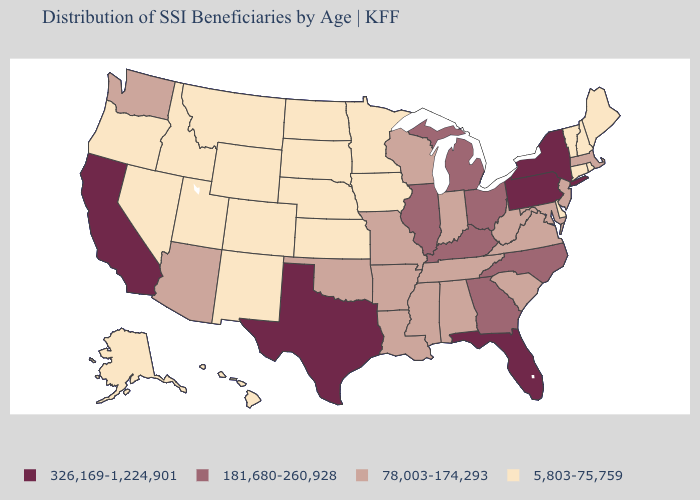Does the first symbol in the legend represent the smallest category?
Be succinct. No. Does Connecticut have the same value as New Jersey?
Concise answer only. No. Which states have the lowest value in the West?
Short answer required. Alaska, Colorado, Hawaii, Idaho, Montana, Nevada, New Mexico, Oregon, Utah, Wyoming. What is the value of North Carolina?
Answer briefly. 181,680-260,928. What is the value of California?
Give a very brief answer. 326,169-1,224,901. Does Pennsylvania have the highest value in the Northeast?
Be succinct. Yes. Name the states that have a value in the range 78,003-174,293?
Concise answer only. Alabama, Arizona, Arkansas, Indiana, Louisiana, Maryland, Massachusetts, Mississippi, Missouri, New Jersey, Oklahoma, South Carolina, Tennessee, Virginia, Washington, West Virginia, Wisconsin. Does Nevada have the same value as Vermont?
Be succinct. Yes. Does Pennsylvania have the highest value in the Northeast?
Give a very brief answer. Yes. What is the lowest value in the Northeast?
Concise answer only. 5,803-75,759. Does Illinois have the same value as North Carolina?
Give a very brief answer. Yes. Is the legend a continuous bar?
Keep it brief. No. Name the states that have a value in the range 78,003-174,293?
Be succinct. Alabama, Arizona, Arkansas, Indiana, Louisiana, Maryland, Massachusetts, Mississippi, Missouri, New Jersey, Oklahoma, South Carolina, Tennessee, Virginia, Washington, West Virginia, Wisconsin. What is the value of South Dakota?
Concise answer only. 5,803-75,759. What is the highest value in states that border Nevada?
Write a very short answer. 326,169-1,224,901. 